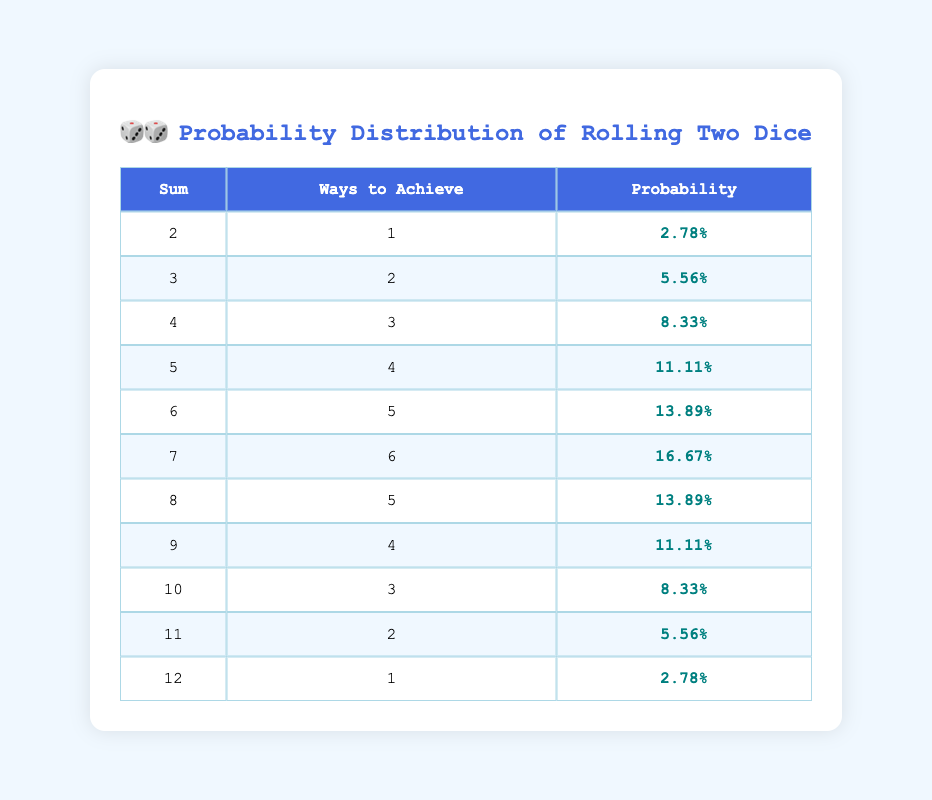What is the probability of rolling a sum of 7? The table shows that the probability of rolling a sum of 7 is 0.1667, which can be found directly in the third column corresponding to the row for a sum of 7.
Answer: 0.1667 How many ways can you achieve a sum of 4? According to the table, the number of ways to achieve a sum of 4 is listed as 3 in the second column for that row.
Answer: 3 Is it true that there are more ways to achieve a sum of 6 than a sum of 5? In the table, the number of ways to achieve a sum of 6 is 5, while for a sum of 5, it is 4. Since 5 is greater than 4, the statement is true.
Answer: Yes What is the average probability of obtaining a sum greater than 7? The sums greater than 7 are 8, 9, 10, 11, and 12, with probabilities of 0.1389, 0.1111, 0.0833, 0.0556, and 0.0278 respectively. Adding these probabilities gives 0.4167. There are 5 sums, so the average is 0.4167 / 5 = 0.0833.
Answer: 0.0833 What is the sum of the probabilities of achieving the highest and the lowest outcomes? The highest outcome is 12 with a probability of 0.0278 and the lowest is 2 with a probability of the same value, 0.0278. The sum is therefore 0.0278 + 0.0278 = 0.0556.
Answer: 0.0556 How many total possible outcomes are there while rolling two dice? The total possible outcomes when rolling two dice is 6 (from the first die) multiplied by 6 (from the second die), which gives a total of 36 possible outcomes. This is a well-known fact from probability theory.
Answer: 36 What is the difference in probability between achieving a sum of 10 and a sum of 8? The probability of achieving a sum of 10 is 0.0833, and for a sum of 8 it is 0.1389. The difference is calculated as 0.1389 - 0.0833 = 0.0556.
Answer: 0.0556 Are there any sums with a probability greater than 0.15? By examining the table, the only sum with a probability greater than 0.15 is the sum of 7, which has a probability of 0.1667. Therefore, there is one sum that meets this criterion.
Answer: Yes 